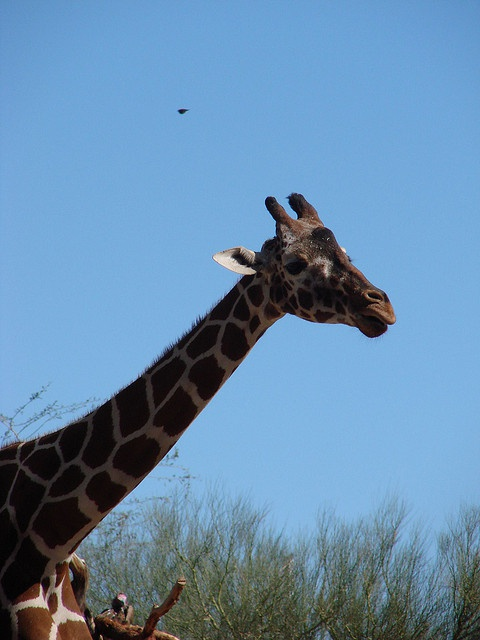Describe the objects in this image and their specific colors. I can see giraffe in gray, black, lightblue, and maroon tones and bird in gray, black, teal, and lightblue tones in this image. 